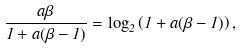<formula> <loc_0><loc_0><loc_500><loc_500>\frac { a \beta } { 1 + a ( \beta - 1 ) } = \log _ { 2 } \left ( 1 + a ( \beta - 1 ) \right ) ,</formula> 